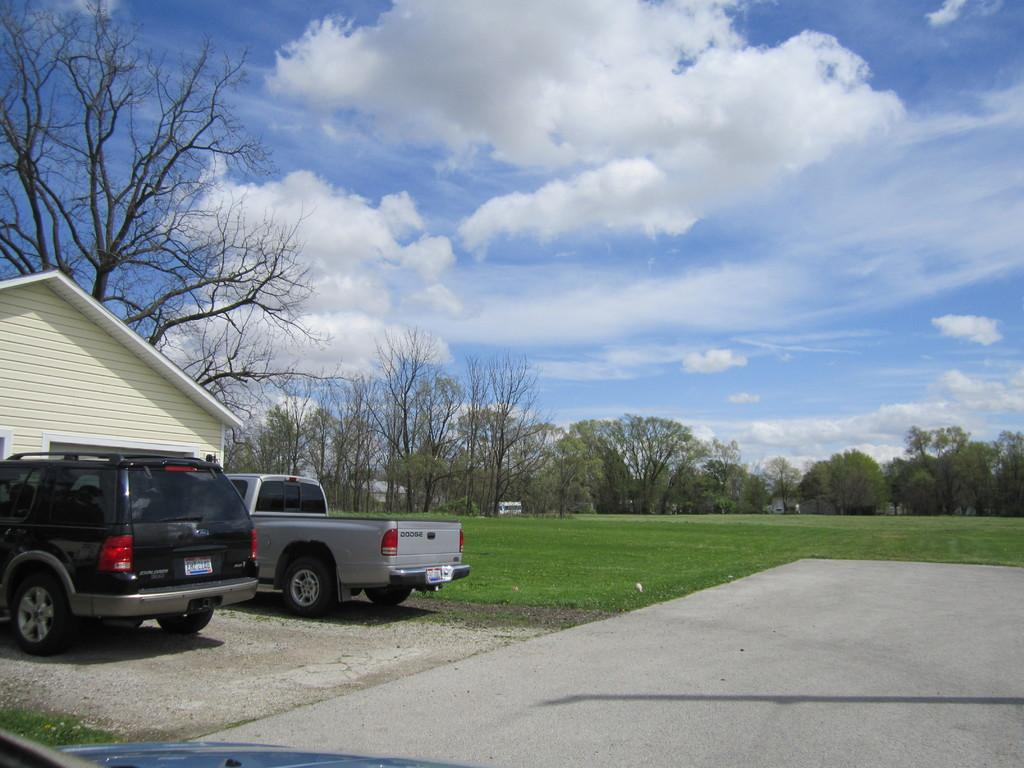What structure is the main subject of the image? There is a building in the image. What can be seen in front of the building? Two vehicles are parked in front of the building. What is visible in the background of the image? There are trees and another building in the background of the image. How would you describe the sky in the image? The sky is cloudy in the image. Is there a liquid pouring out of the building in the image? No, there is no liquid pouring out of the building in the image. Can you see an aunt playing with children in the image? No, there is no aunt or children present in the image. 